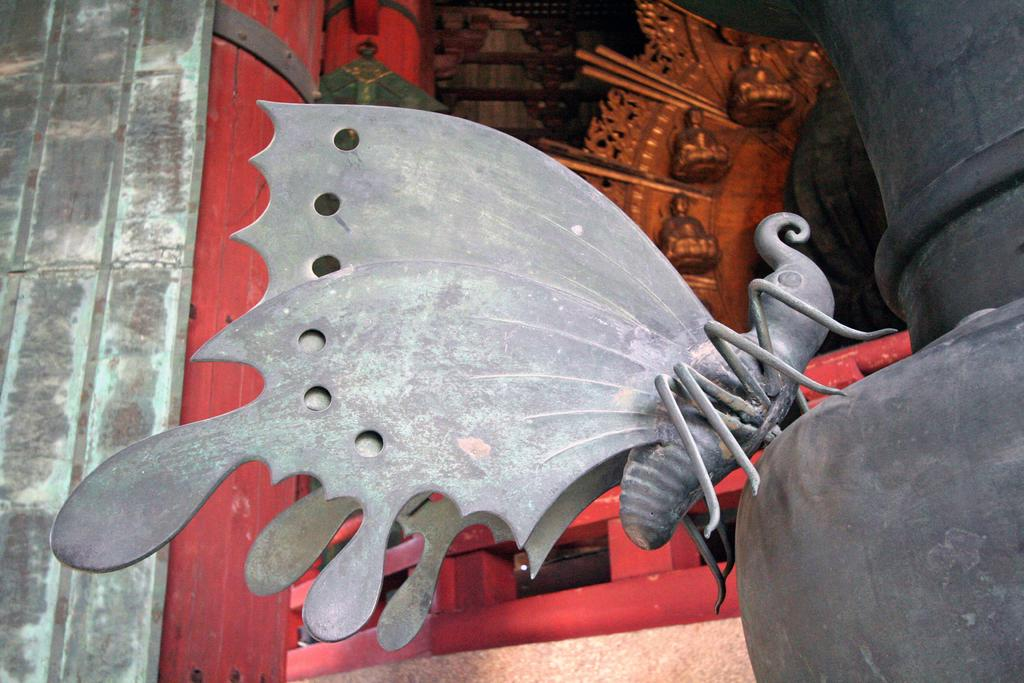What is the main subject in the foreground of the image? There is a model of a butterfly in the foreground of the image. How is the butterfly model positioned in the image? The butterfly model is on a pole-like structure. What can be seen in the background of the image? There is a wall and a railing in the background of the image, as well as sculptures on a gold surface. How many legs does the question have in the image? There is no question present in the image, and therefore no legs can be attributed to it. 